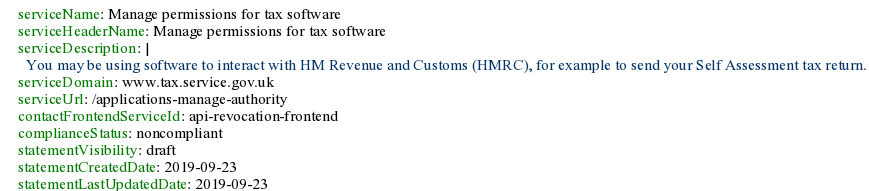<code> <loc_0><loc_0><loc_500><loc_500><_YAML_>serviceName: Manage permissions for tax software
serviceHeaderName: Manage permissions for tax software
serviceDescription: |
  You may be using software to interact with HM Revenue and Customs (HMRC), for example to send your Self Assessment tax return.
serviceDomain: www.tax.service.gov.uk
serviceUrl: /applications-manage-authority
contactFrontendServiceId: api-revocation-frontend
complianceStatus: noncompliant
statementVisibility: draft
statementCreatedDate: 2019-09-23
statementLastUpdatedDate: 2019-09-23
</code> 